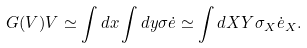Convert formula to latex. <formula><loc_0><loc_0><loc_500><loc_500>G ( V ) V \simeq \int d x \int d y \sigma \dot { e } \simeq \int d X Y \sigma _ { X } \dot { e } _ { X } .</formula> 